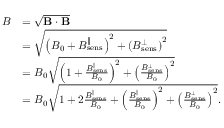<formula> <loc_0><loc_0><loc_500><loc_500>\begin{array} { r l } { B } & { = \sqrt { B \cdot B } } \\ & { = \sqrt { \left ( B _ { 0 } + B _ { s e n s } ^ { \| } \right ) ^ { 2 } + \left ( B _ { s e n s } ^ { \perp } \right ) ^ { 2 } } } \\ & { = B _ { 0 } \sqrt { \left ( 1 + \frac { B _ { s e n s } ^ { \| } } { B _ { 0 } } \right ) ^ { 2 } + \left ( \frac { B _ { s e n s } ^ { \perp } } { B _ { 0 } } \right ) ^ { 2 } } } \\ & { = B _ { 0 } \sqrt { 1 + 2 \frac { B _ { s e n s } ^ { \| } } { B _ { 0 } } + \left ( \frac { B _ { s e n s } ^ { \| } } { B _ { 0 } } \right ) ^ { 2 } + \left ( \frac { B _ { s e n s } ^ { \perp } } { B _ { 0 } } \right ) ^ { 2 } } . } \end{array}</formula> 